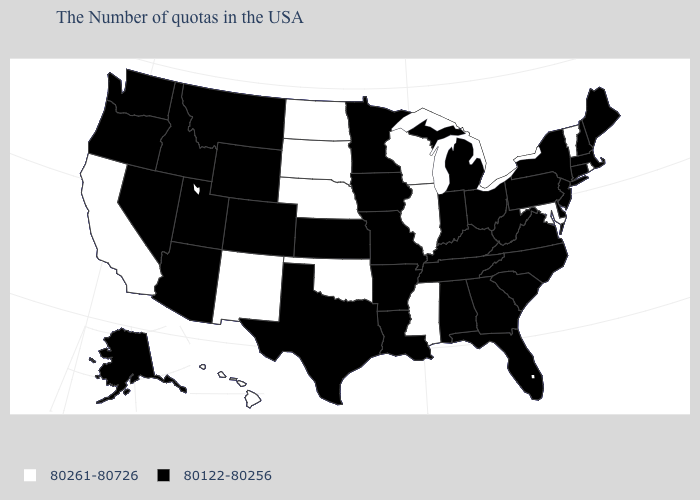What is the value of Colorado?
Be succinct. 80122-80256. Name the states that have a value in the range 80261-80726?
Concise answer only. Rhode Island, Vermont, Maryland, Wisconsin, Illinois, Mississippi, Nebraska, Oklahoma, South Dakota, North Dakota, New Mexico, California, Hawaii. Which states have the lowest value in the MidWest?
Give a very brief answer. Ohio, Michigan, Indiana, Missouri, Minnesota, Iowa, Kansas. What is the value of Virginia?
Write a very short answer. 80122-80256. What is the value of Arkansas?
Be succinct. 80122-80256. Among the states that border Minnesota , which have the lowest value?
Quick response, please. Iowa. Is the legend a continuous bar?
Be succinct. No. Does Rhode Island have the lowest value in the Northeast?
Give a very brief answer. No. What is the highest value in the South ?
Give a very brief answer. 80261-80726. What is the highest value in the USA?
Be succinct. 80261-80726. Name the states that have a value in the range 80122-80256?
Short answer required. Maine, Massachusetts, New Hampshire, Connecticut, New York, New Jersey, Delaware, Pennsylvania, Virginia, North Carolina, South Carolina, West Virginia, Ohio, Florida, Georgia, Michigan, Kentucky, Indiana, Alabama, Tennessee, Louisiana, Missouri, Arkansas, Minnesota, Iowa, Kansas, Texas, Wyoming, Colorado, Utah, Montana, Arizona, Idaho, Nevada, Washington, Oregon, Alaska. What is the lowest value in the West?
Give a very brief answer. 80122-80256. Is the legend a continuous bar?
Keep it brief. No. Name the states that have a value in the range 80122-80256?
Give a very brief answer. Maine, Massachusetts, New Hampshire, Connecticut, New York, New Jersey, Delaware, Pennsylvania, Virginia, North Carolina, South Carolina, West Virginia, Ohio, Florida, Georgia, Michigan, Kentucky, Indiana, Alabama, Tennessee, Louisiana, Missouri, Arkansas, Minnesota, Iowa, Kansas, Texas, Wyoming, Colorado, Utah, Montana, Arizona, Idaho, Nevada, Washington, Oregon, Alaska. Among the states that border Kentucky , which have the lowest value?
Keep it brief. Virginia, West Virginia, Ohio, Indiana, Tennessee, Missouri. 